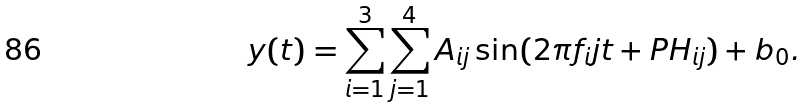Convert formula to latex. <formula><loc_0><loc_0><loc_500><loc_500>y ( t ) = \sum _ { i = 1 } ^ { 3 } \sum _ { j = 1 } ^ { 4 } A _ { i j } \sin ( 2 \pi f _ { i } j t + P H _ { i j } ) + b _ { 0 } .</formula> 